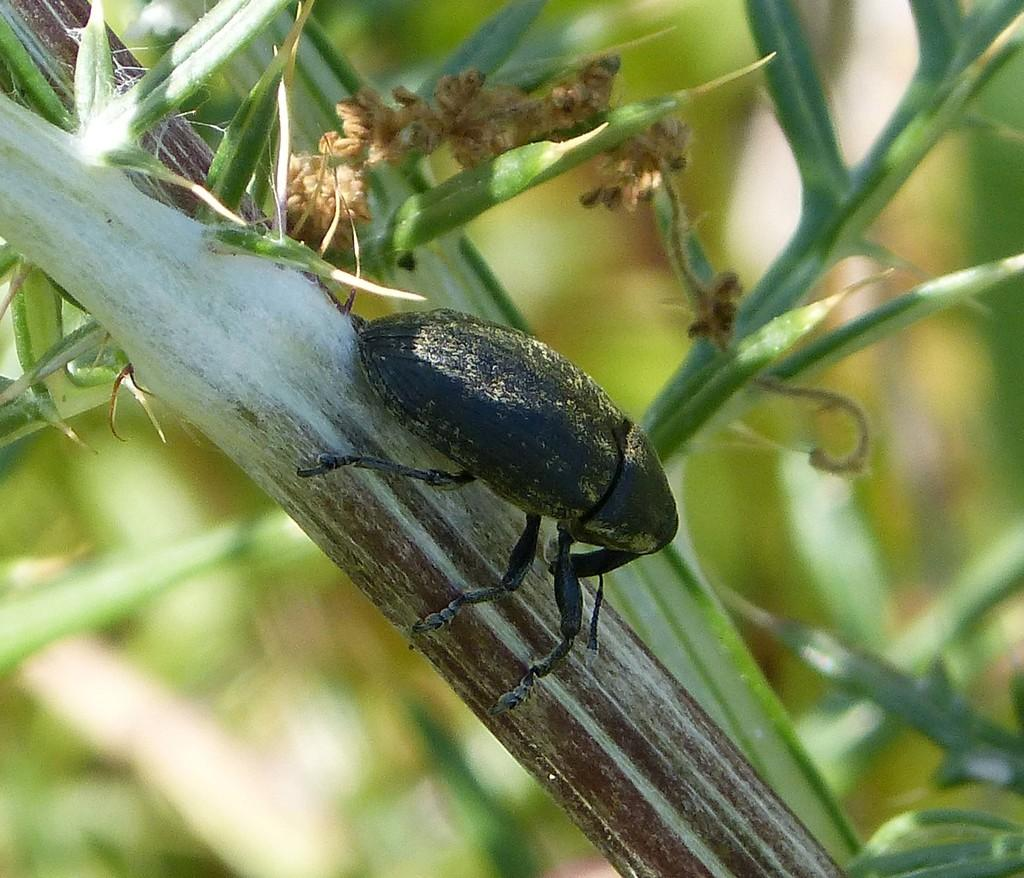What can be observed about the background of the image? The background of the image is blurred. What else is visible in the image besides the blurred background? There are stems visible in the image. Can you describe any living organisms present in the image? Yes, there is a black insect on a stem in the image. How does the earthquake affect the top of the bead in the image? There is no earthquake or bead present in the image, so this question cannot be answered. 